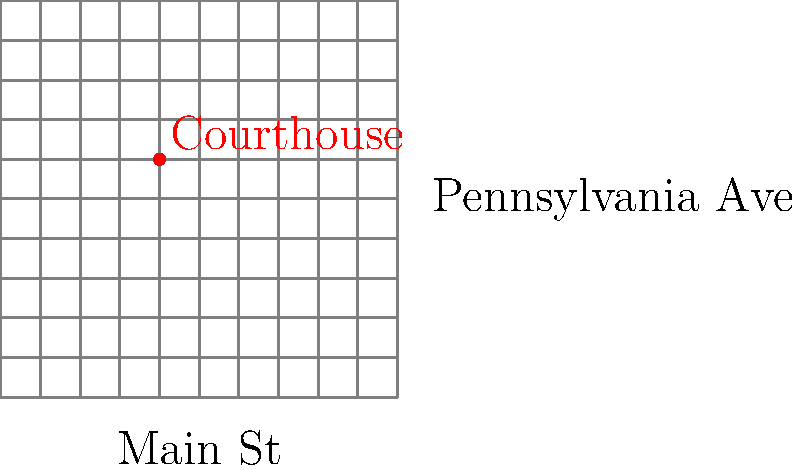On the Greensburg city map grid, the courthouse is located at the intersection of Main Street and Pennsylvania Avenue. If each grid unit represents one city block, what are the coordinates of the Greensburg Courthouse? Express your answer as an ordered pair $(x,y)$. To find the coordinates of the Greensburg Courthouse, we need to follow these steps:

1. Identify the origin (0,0) of the coordinate system, which is at the bottom-left corner of the grid.

2. Locate the red dot representing the courthouse on the grid.

3. Count the number of units along the x-axis (horizontally) from the origin to the courthouse:
   - The courthouse is 3 units to the right of the origin.

4. Count the number of units along the y-axis (vertically) from the origin to the courthouse:
   - The courthouse is 5 units up from the origin.

5. Express the location as an ordered pair $(x,y)$, where:
   - $x$ is the horizontal distance from the origin
   - $y$ is the vertical distance from the origin

Therefore, the coordinates of the Greensburg Courthouse are $(3,5)$.
Answer: $(3,5)$ 